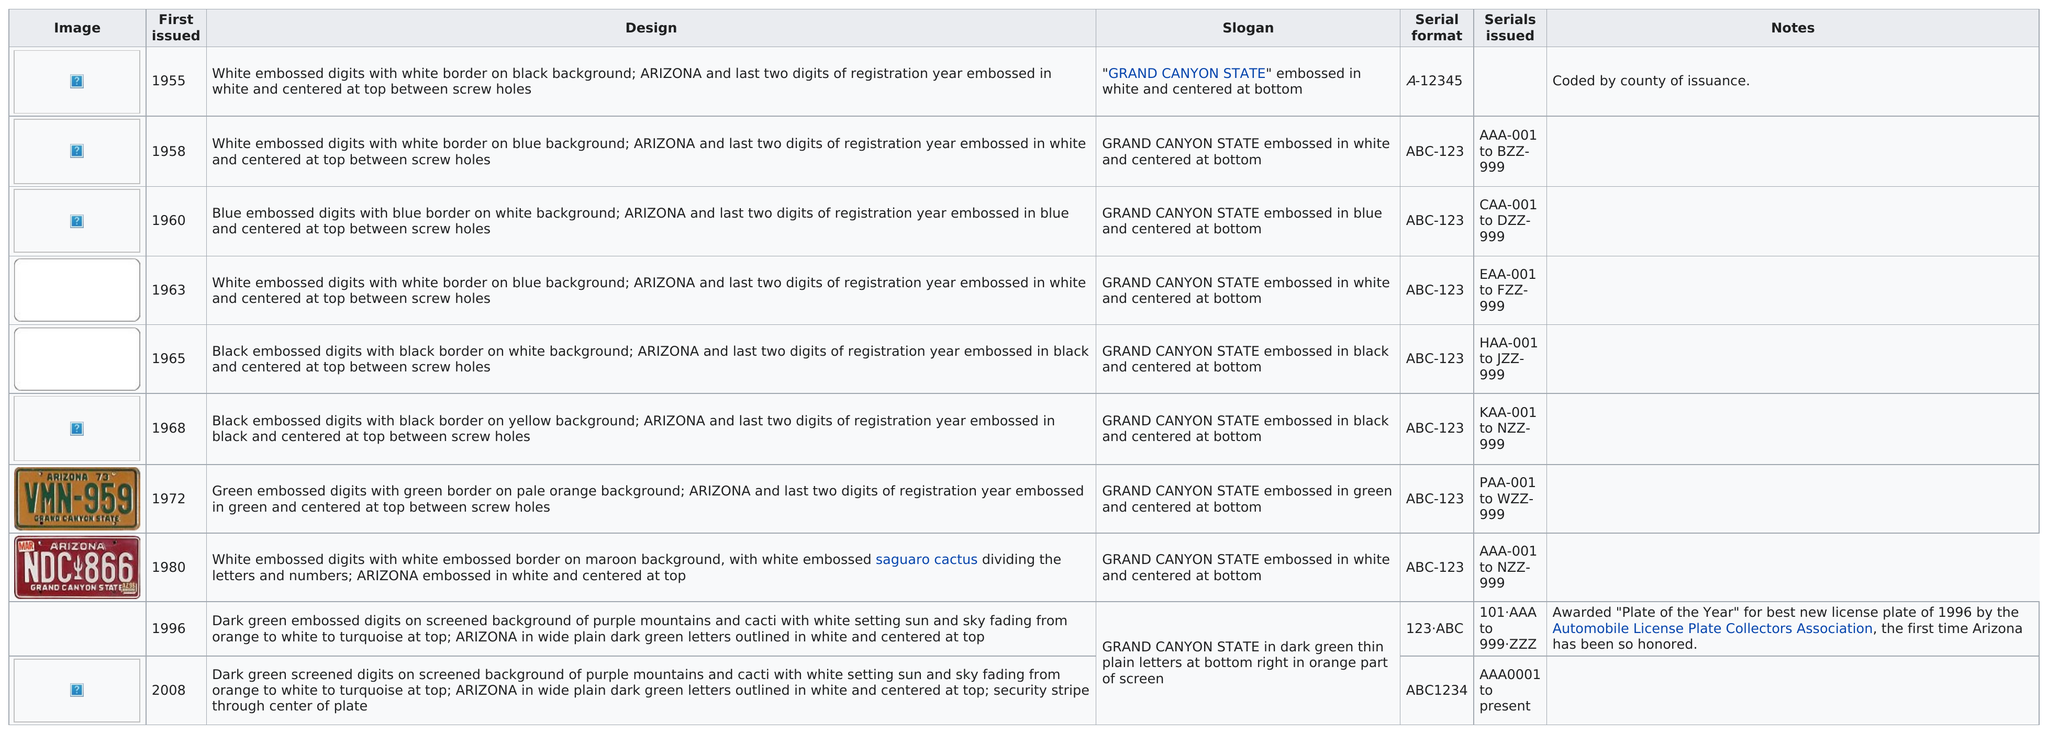Indicate a few pertinent items in this graphic. In the year that featured the license plate with the least characters, 1955, the license plate had only one character. In the year 1996, the State of Arizona was awarded the title of "Plate of the Year" by the Automobile License Plate Collectors Association for producing the best new passenger license plate. Please name the year of the license plate with the largest number of alphanumeric digits, which is 2008. In 2008, if you had requested customized His and Her state passenger automobile license plates with dark green screened digits on a screened background of purple mountains and cacti with a white setting sun and sky fading from orange to white to turquoise at the top, the state of Arizona would have issued the license plates to you. Since 1955, during every consecutive year, the state slogan "Grand Canyon State" has appeared embossed on passenger vehicle license plates issued by the State of Arizona. 